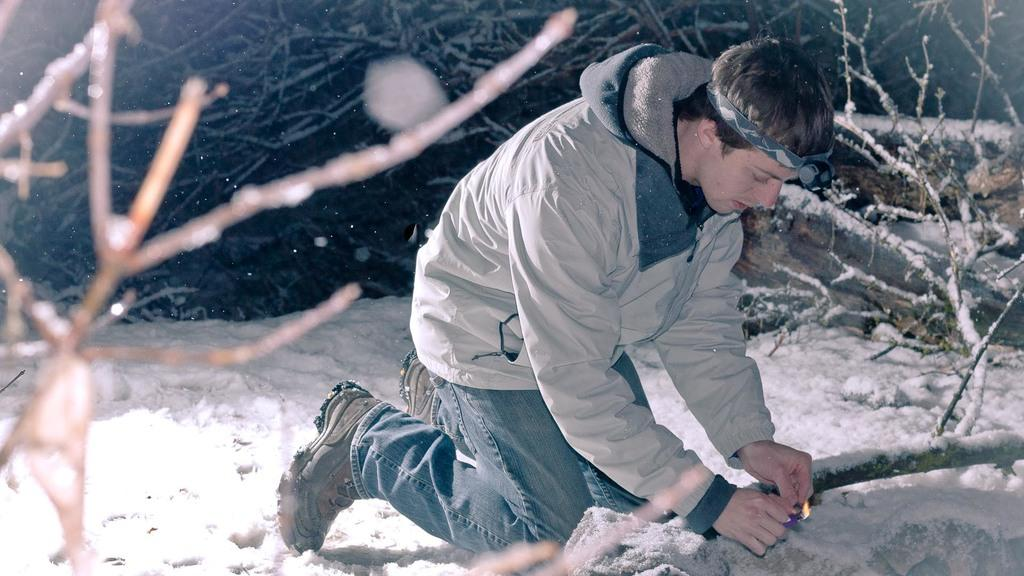Who is present in the image? There is a man in the image. What is the man holding in his hand? The man is holding fire in his hand. What type of natural environment can be seen in the image? There are trees visible in the image. What is the ground covered with in the image? There is snow on the ground in the image. What type of plants can be seen growing in the pail in the image? There is no pail present in the image, and therefore no plants can be seen growing in it. 